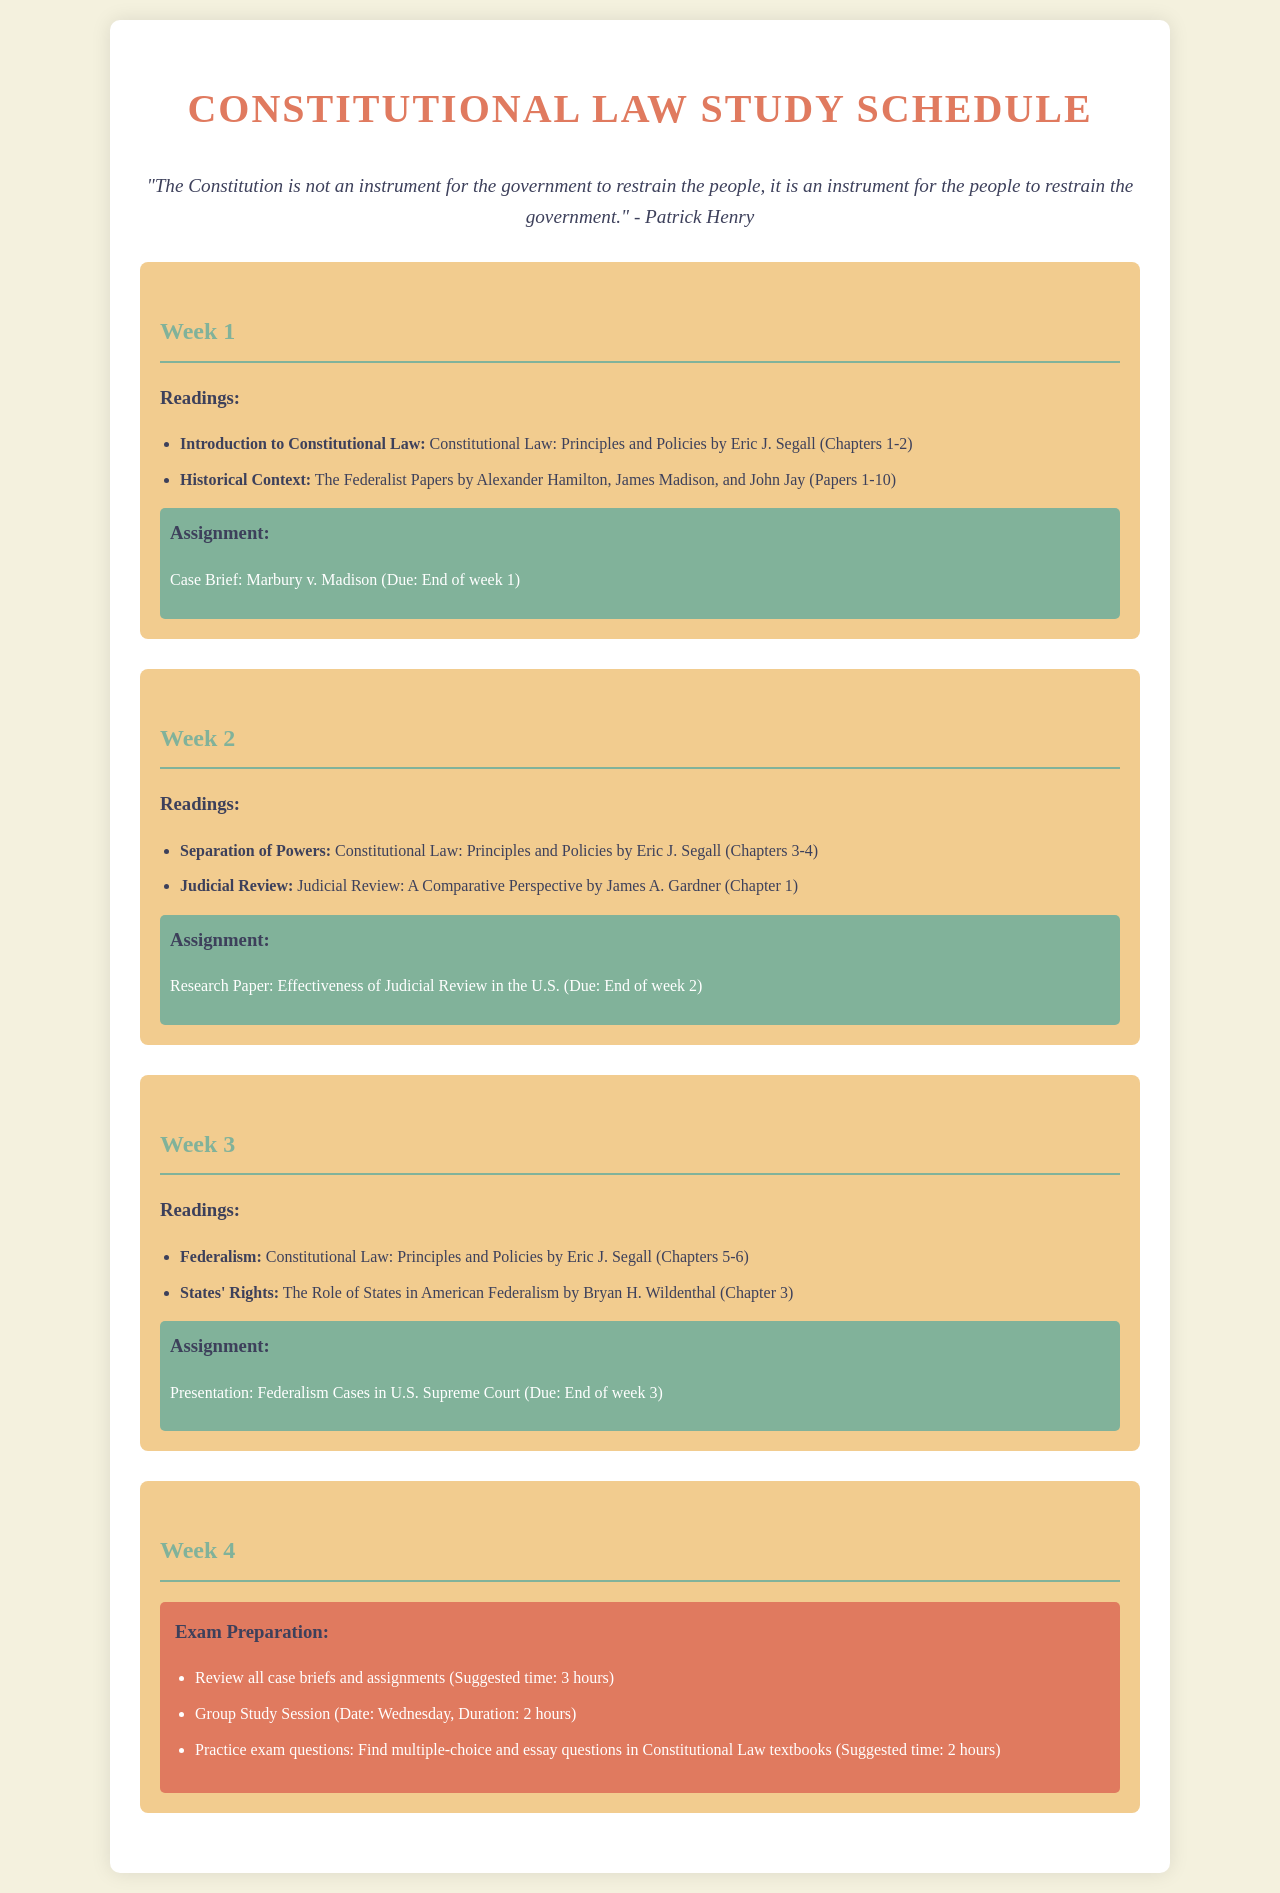What is the title of the document? The title of the document is prominently displayed at the top of the page, indicating the focus of the content.
Answer: Constitutional Law Study Schedule Who is the author of the book on Constitutional Law principles? The author of the book mentioned in the readings for Week 1 is listed, providing a key reference for the course.
Answer: Eric J. Segall What case is assigned for a brief in Week 1? The assignment in Week 1 specifies a particular landmark case that students need to analyze, relevant to the course materials.
Answer: Marbury v. Madison How many groups are suggested for the group study session in Week 4? The preparation section in Week 4 indicates a collaboration method for studying, specifically mentioning a session.
Answer: 1 What chapters are covered in Week 2 readings? The readings section for Week 2 identifies specific chapters in a textbook that students are expected to study, linking to a broader understanding of the topic.
Answer: Chapters 3-4 What type of project is due at the end of Week 3? The assignment for Week 3 specifies the nature of the evaluation task students will work on relating to federalism cases, indicating a practical application of the material.
Answer: Presentation What is the duration of the suggested time for practicing exam questions in Week 4? The exam preparation section provides a specific time recommendation for students to efficiently review practice questions, important for their exam readiness.
Answer: 2 hours Which day is the group study session scheduled for in Week 4? The preparation section specifies a day for a group study session, allowing students to collaborate on course content prior to exams.
Answer: Wednesday How many papers from The Federalist Papers are assigned in Week 1? The readings for Week 1 count the specific number of Federalist Papers assigned for study, outlining the historical context.
Answer: 10 